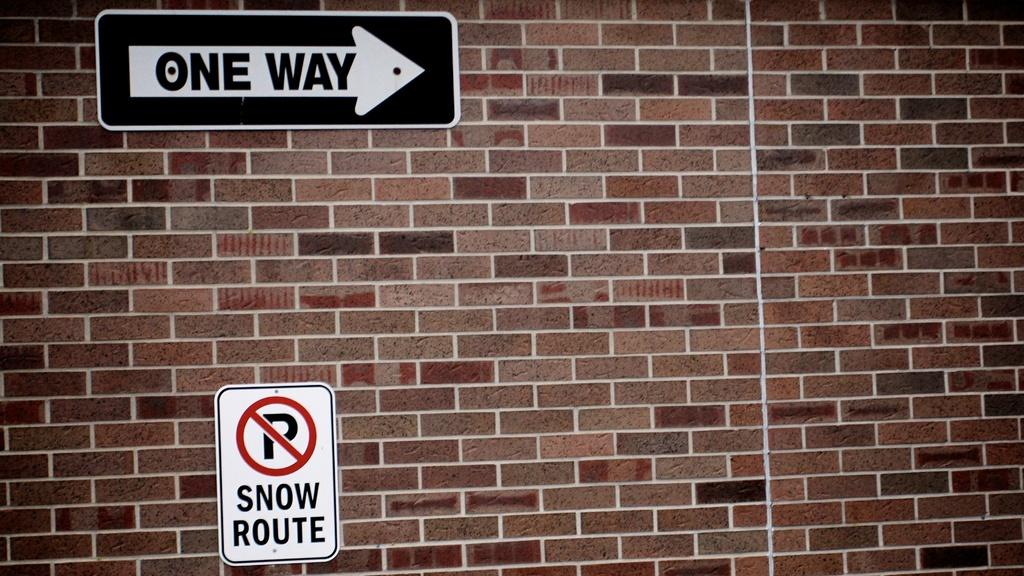<image>
Relay a brief, clear account of the picture shown. A one way sign is above a sign that says Snow Route on a brick wall. 